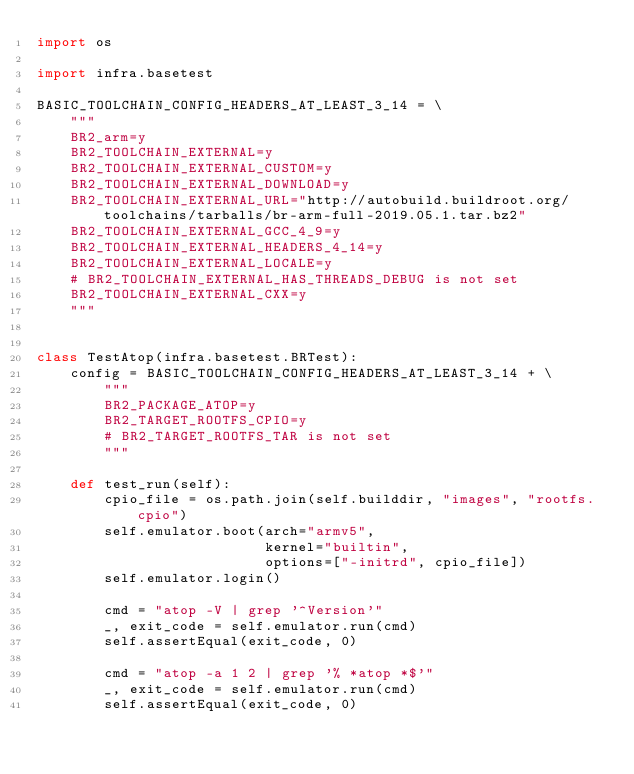Convert code to text. <code><loc_0><loc_0><loc_500><loc_500><_Python_>import os

import infra.basetest

BASIC_TOOLCHAIN_CONFIG_HEADERS_AT_LEAST_3_14 = \
    """
    BR2_arm=y
    BR2_TOOLCHAIN_EXTERNAL=y
    BR2_TOOLCHAIN_EXTERNAL_CUSTOM=y
    BR2_TOOLCHAIN_EXTERNAL_DOWNLOAD=y
    BR2_TOOLCHAIN_EXTERNAL_URL="http://autobuild.buildroot.org/toolchains/tarballs/br-arm-full-2019.05.1.tar.bz2"
    BR2_TOOLCHAIN_EXTERNAL_GCC_4_9=y
    BR2_TOOLCHAIN_EXTERNAL_HEADERS_4_14=y
    BR2_TOOLCHAIN_EXTERNAL_LOCALE=y
    # BR2_TOOLCHAIN_EXTERNAL_HAS_THREADS_DEBUG is not set
    BR2_TOOLCHAIN_EXTERNAL_CXX=y
    """


class TestAtop(infra.basetest.BRTest):
    config = BASIC_TOOLCHAIN_CONFIG_HEADERS_AT_LEAST_3_14 + \
        """
        BR2_PACKAGE_ATOP=y
        BR2_TARGET_ROOTFS_CPIO=y
        # BR2_TARGET_ROOTFS_TAR is not set
        """

    def test_run(self):
        cpio_file = os.path.join(self.builddir, "images", "rootfs.cpio")
        self.emulator.boot(arch="armv5",
                           kernel="builtin",
                           options=["-initrd", cpio_file])
        self.emulator.login()

        cmd = "atop -V | grep '^Version'"
        _, exit_code = self.emulator.run(cmd)
        self.assertEqual(exit_code, 0)

        cmd = "atop -a 1 2 | grep '% *atop *$'"
        _, exit_code = self.emulator.run(cmd)
        self.assertEqual(exit_code, 0)
</code> 